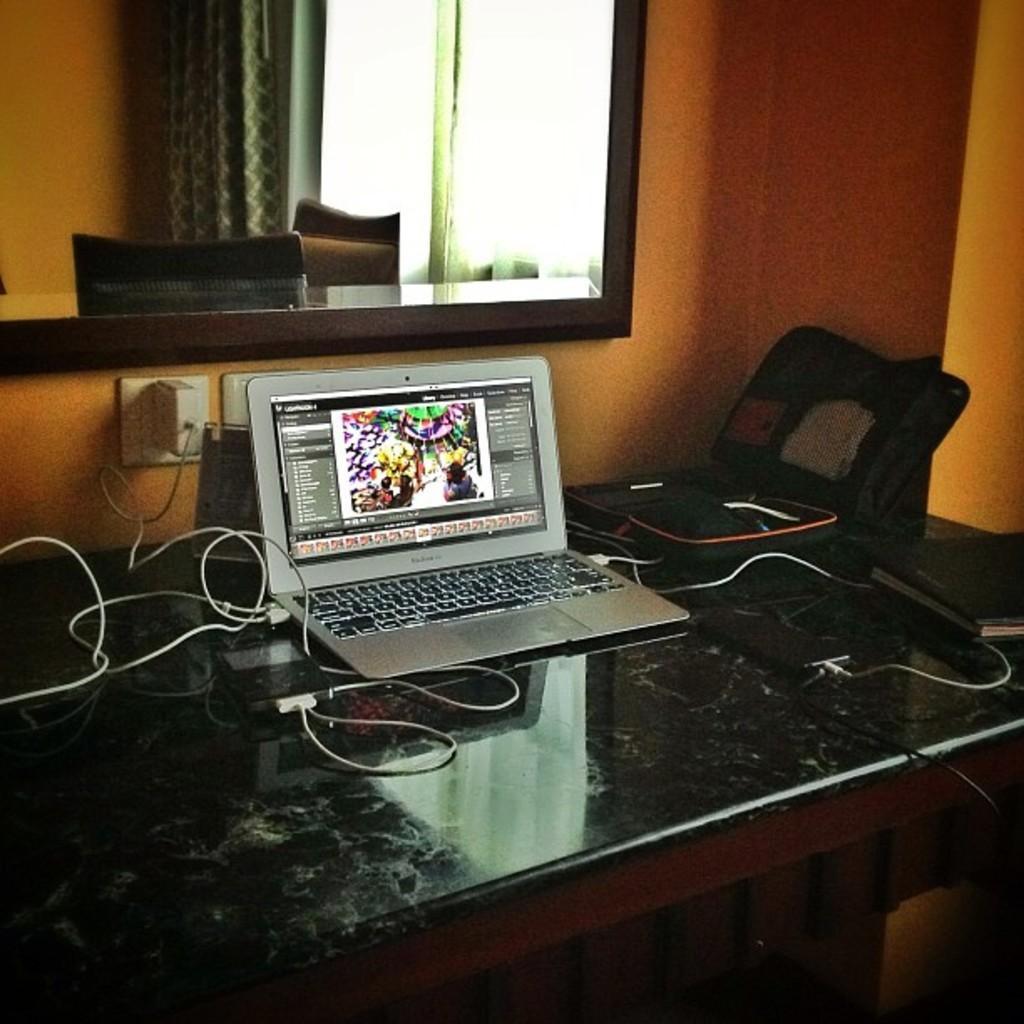In one or two sentences, can you explain what this image depicts? In this image we can see a table which has a laptop on it. There is a book on this table. There are wires, there is a window behind this table. There are chairs and curtain behind that table. 